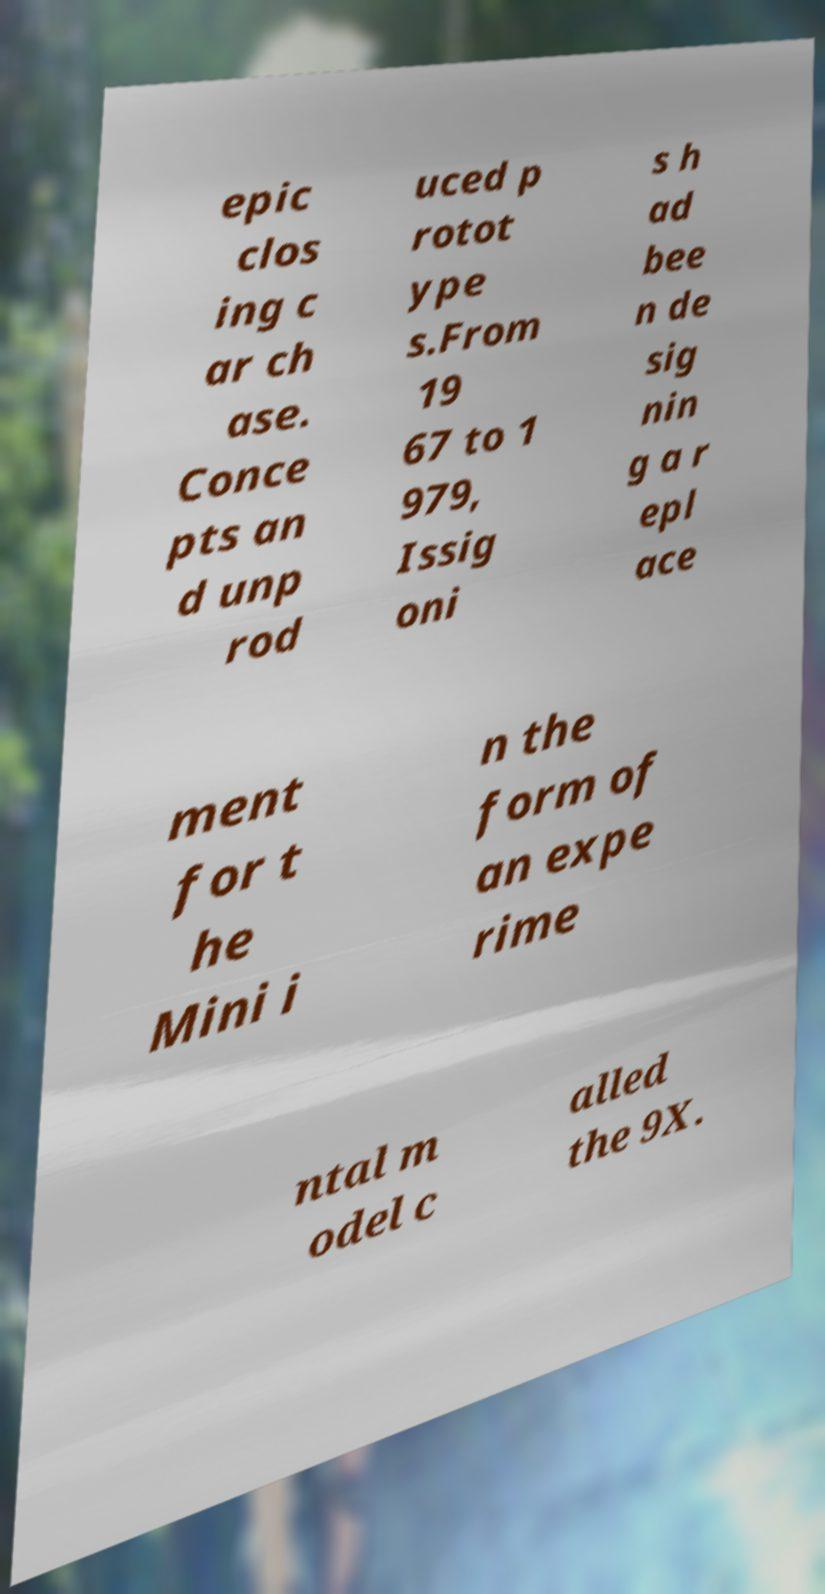Please identify and transcribe the text found in this image. epic clos ing c ar ch ase. Conce pts an d unp rod uced p rotot ype s.From 19 67 to 1 979, Issig oni s h ad bee n de sig nin g a r epl ace ment for t he Mini i n the form of an expe rime ntal m odel c alled the 9X. 